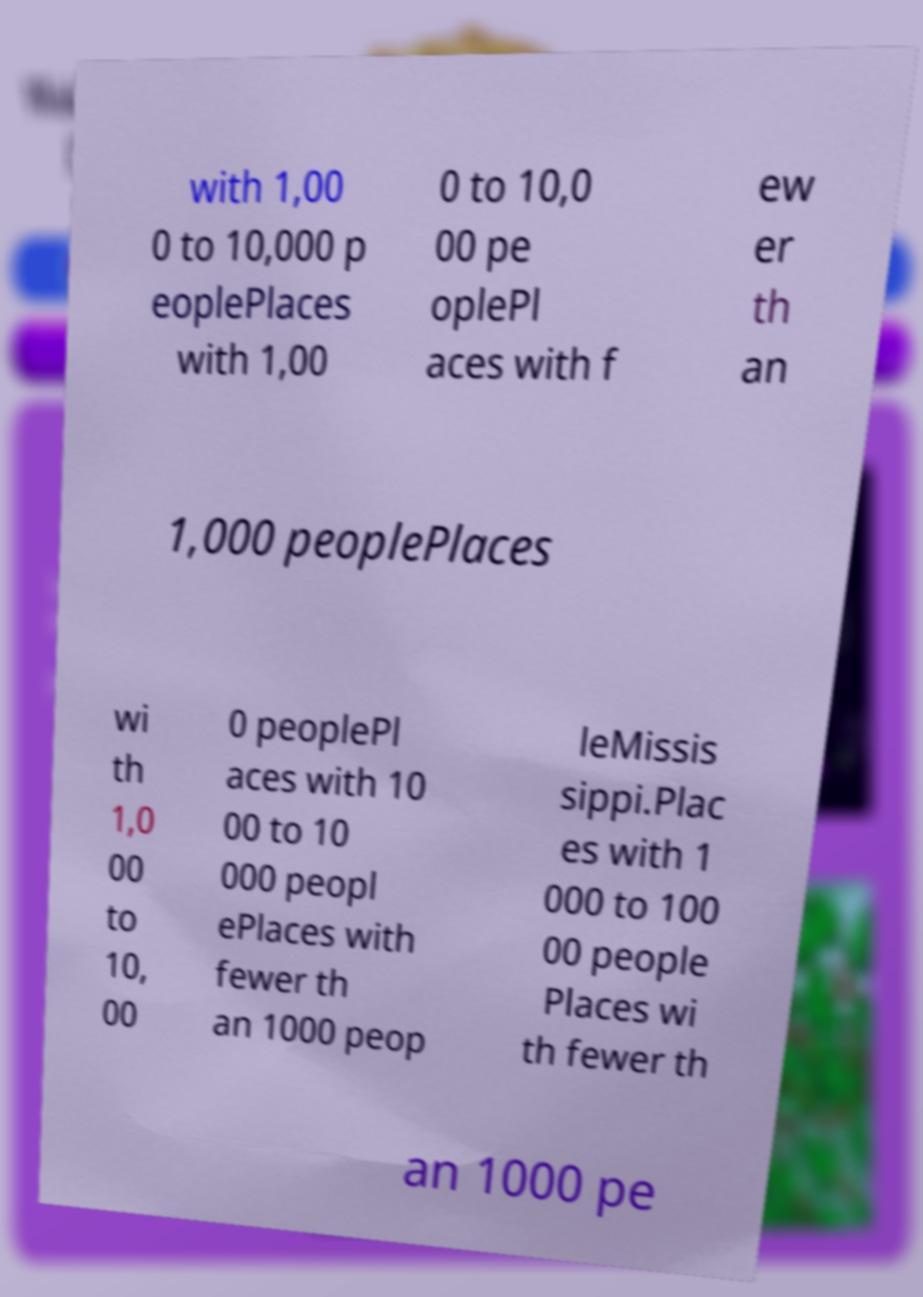Could you assist in decoding the text presented in this image and type it out clearly? with 1,00 0 to 10,000 p eoplePlaces with 1,00 0 to 10,0 00 pe oplePl aces with f ew er th an 1,000 peoplePlaces wi th 1,0 00 to 10, 00 0 peoplePl aces with 10 00 to 10 000 peopl ePlaces with fewer th an 1000 peop leMissis sippi.Plac es with 1 000 to 100 00 people Places wi th fewer th an 1000 pe 